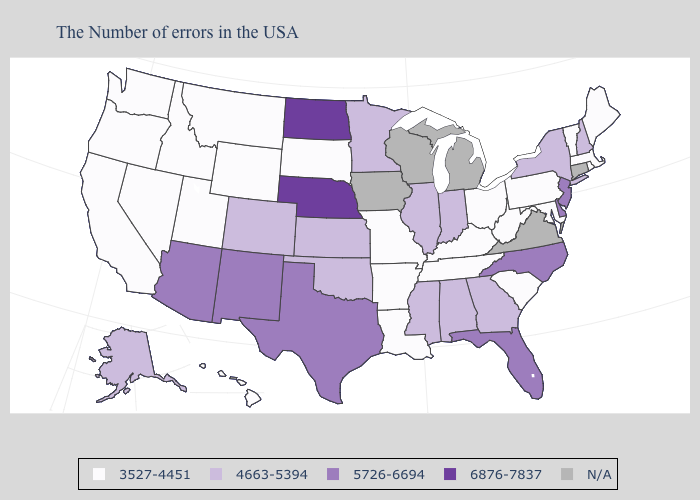What is the value of Delaware?
Keep it brief. 5726-6694. Name the states that have a value in the range 4663-5394?
Quick response, please. New Hampshire, New York, Georgia, Indiana, Alabama, Illinois, Mississippi, Minnesota, Kansas, Oklahoma, Colorado, Alaska. Name the states that have a value in the range N/A?
Quick response, please. Connecticut, Virginia, Michigan, Wisconsin, Iowa. Does the map have missing data?
Write a very short answer. Yes. Does New Mexico have the lowest value in the West?
Give a very brief answer. No. Among the states that border Georgia , which have the lowest value?
Concise answer only. South Carolina, Tennessee. What is the value of Hawaii?
Be succinct. 3527-4451. Name the states that have a value in the range 4663-5394?
Answer briefly. New Hampshire, New York, Georgia, Indiana, Alabama, Illinois, Mississippi, Minnesota, Kansas, Oklahoma, Colorado, Alaska. Is the legend a continuous bar?
Give a very brief answer. No. Name the states that have a value in the range 6876-7837?
Be succinct. Nebraska, North Dakota. Does Montana have the lowest value in the West?
Answer briefly. Yes. What is the value of Utah?
Be succinct. 3527-4451. What is the value of Texas?
Concise answer only. 5726-6694. What is the value of Massachusetts?
Short answer required. 3527-4451. 